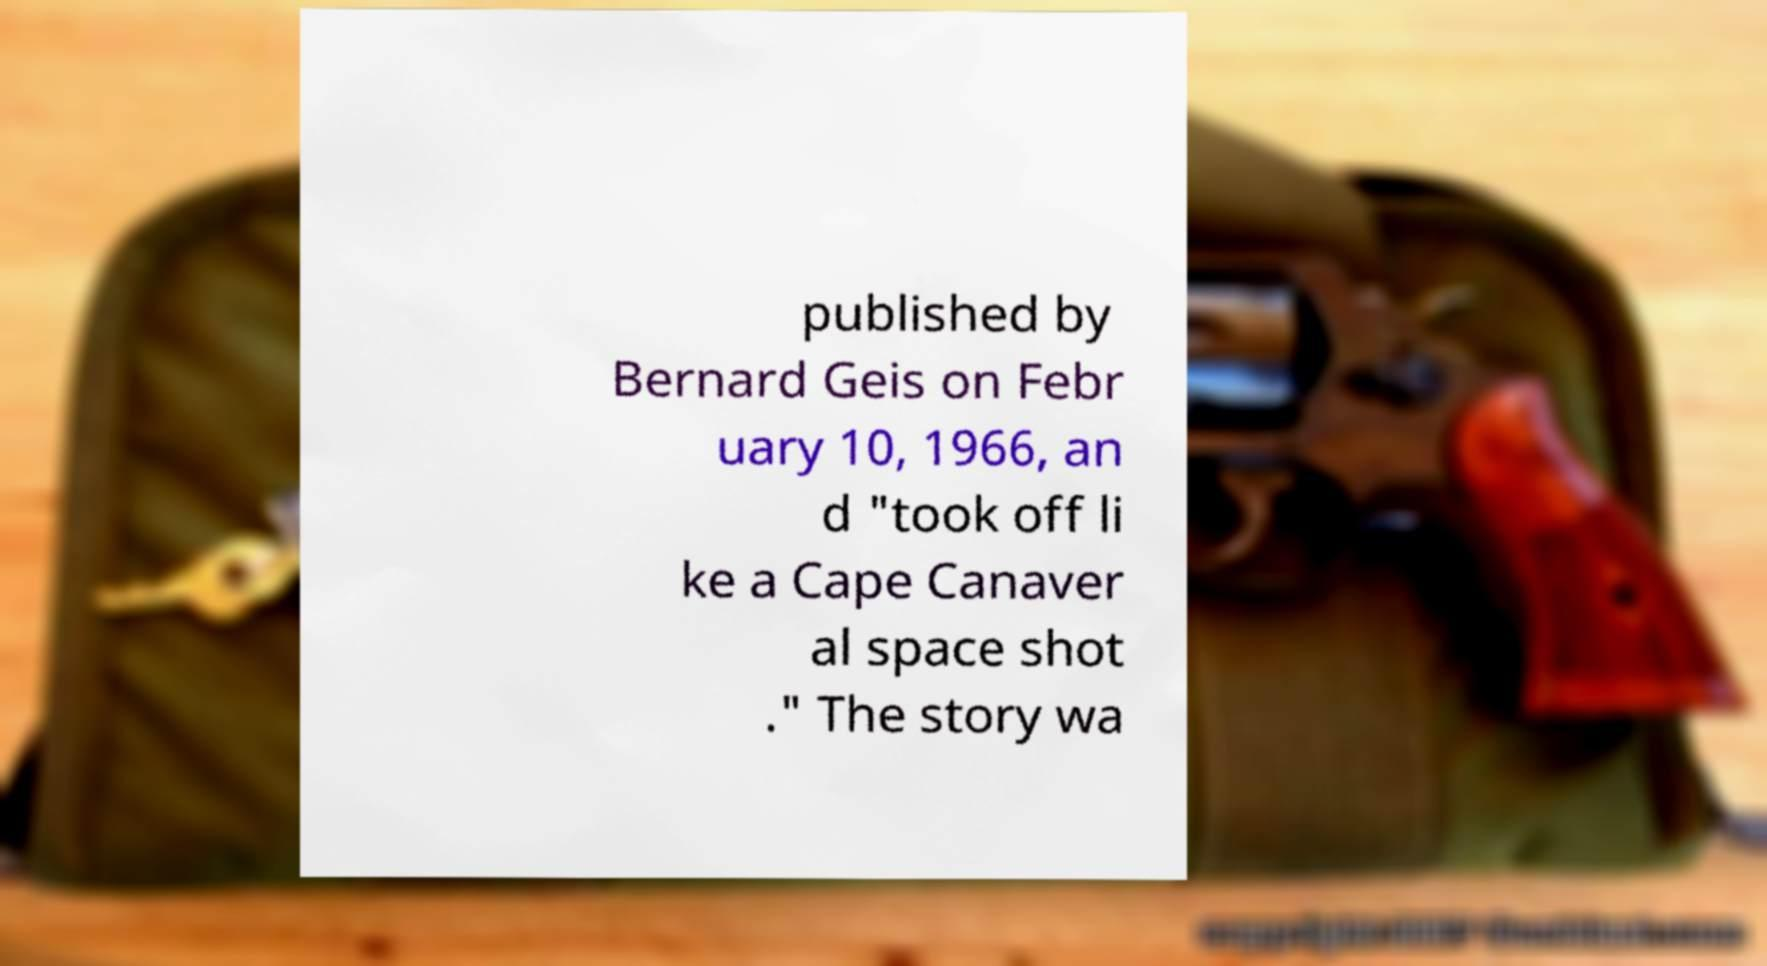Please read and relay the text visible in this image. What does it say? published by Bernard Geis on Febr uary 10, 1966, an d "took off li ke a Cape Canaver al space shot ." The story wa 